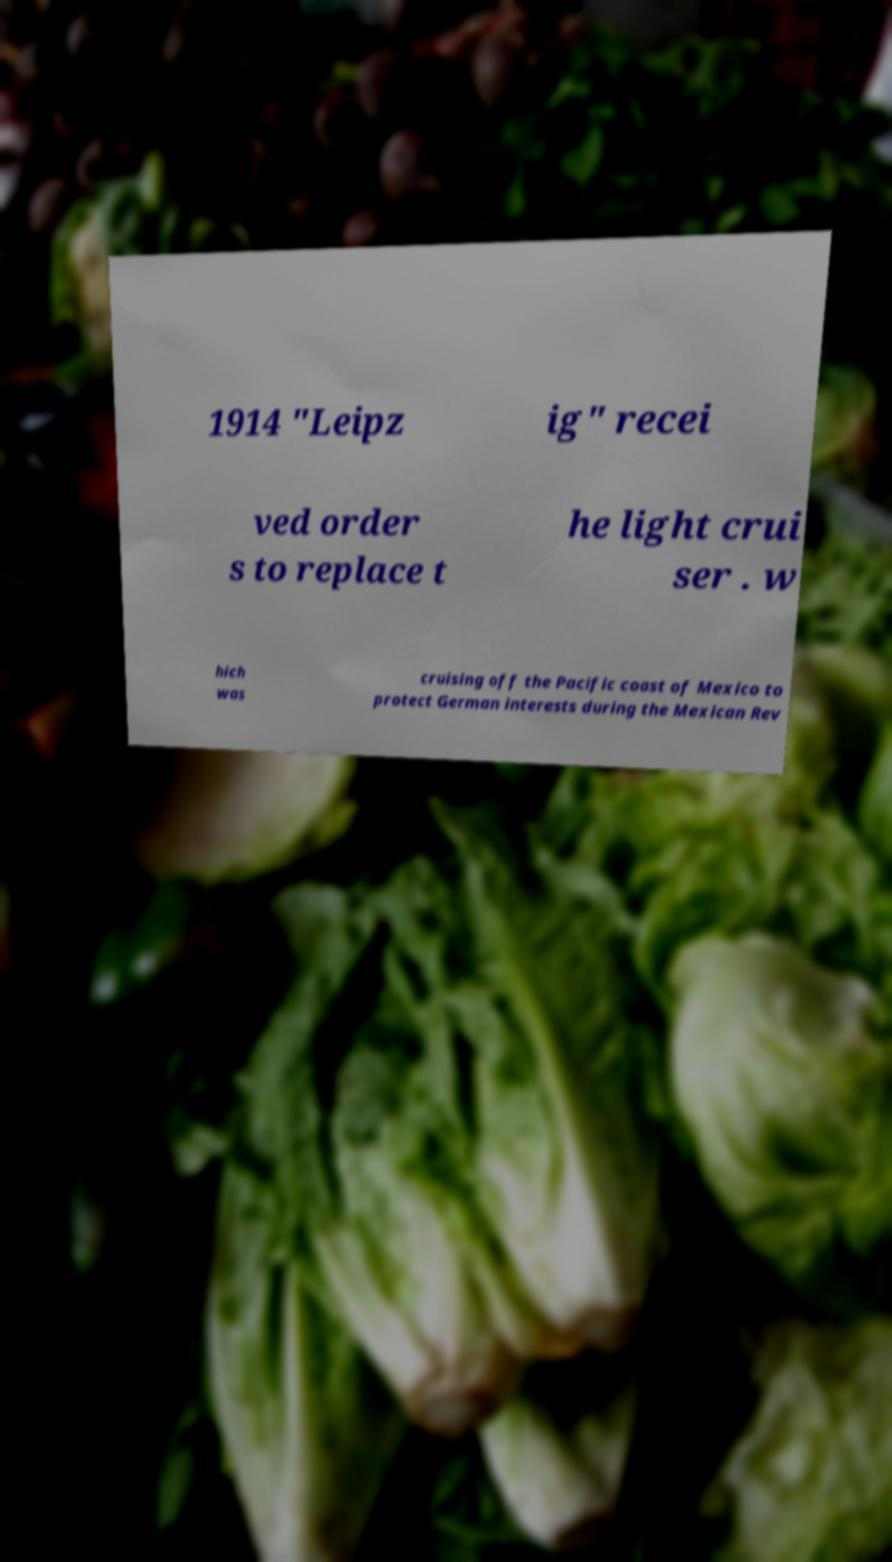Please identify and transcribe the text found in this image. 1914 "Leipz ig" recei ved order s to replace t he light crui ser . w hich was cruising off the Pacific coast of Mexico to protect German interests during the Mexican Rev 